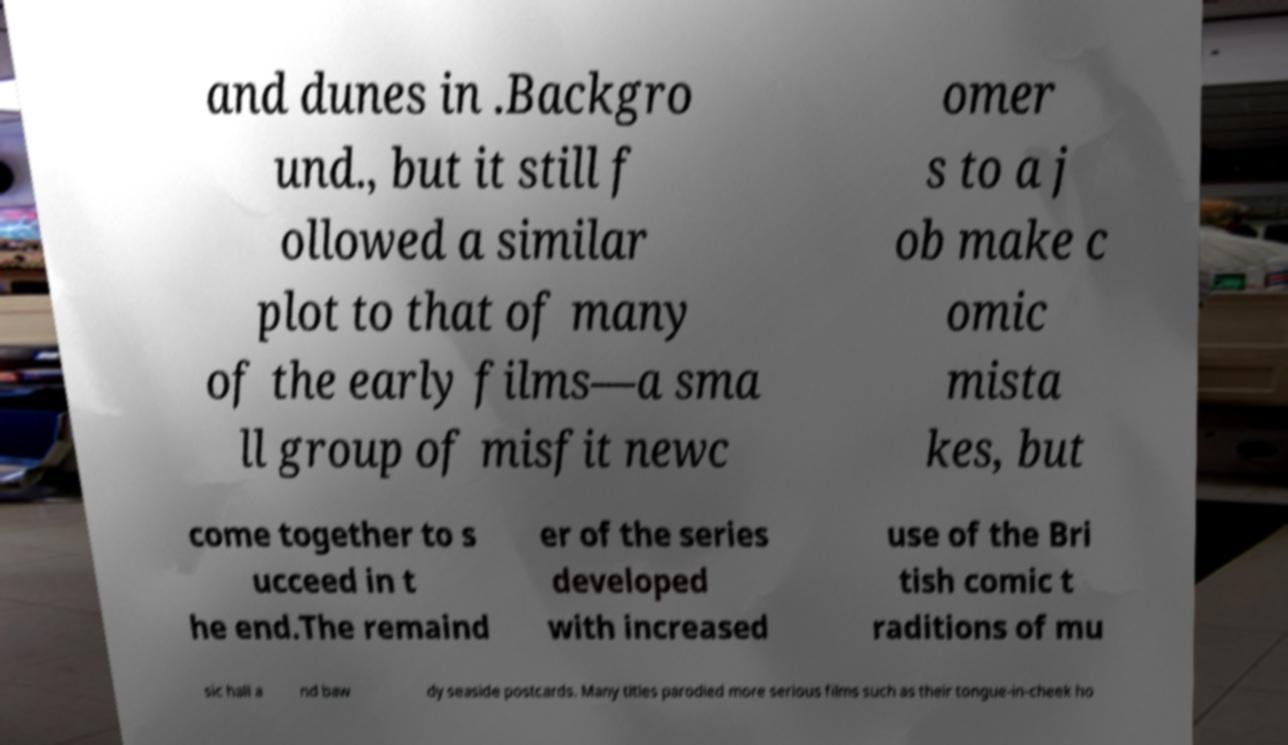Could you extract and type out the text from this image? and dunes in .Backgro und., but it still f ollowed a similar plot to that of many of the early films—a sma ll group of misfit newc omer s to a j ob make c omic mista kes, but come together to s ucceed in t he end.The remaind er of the series developed with increased use of the Bri tish comic t raditions of mu sic hall a nd baw dy seaside postcards. Many titles parodied more serious films such as their tongue-in-cheek ho 